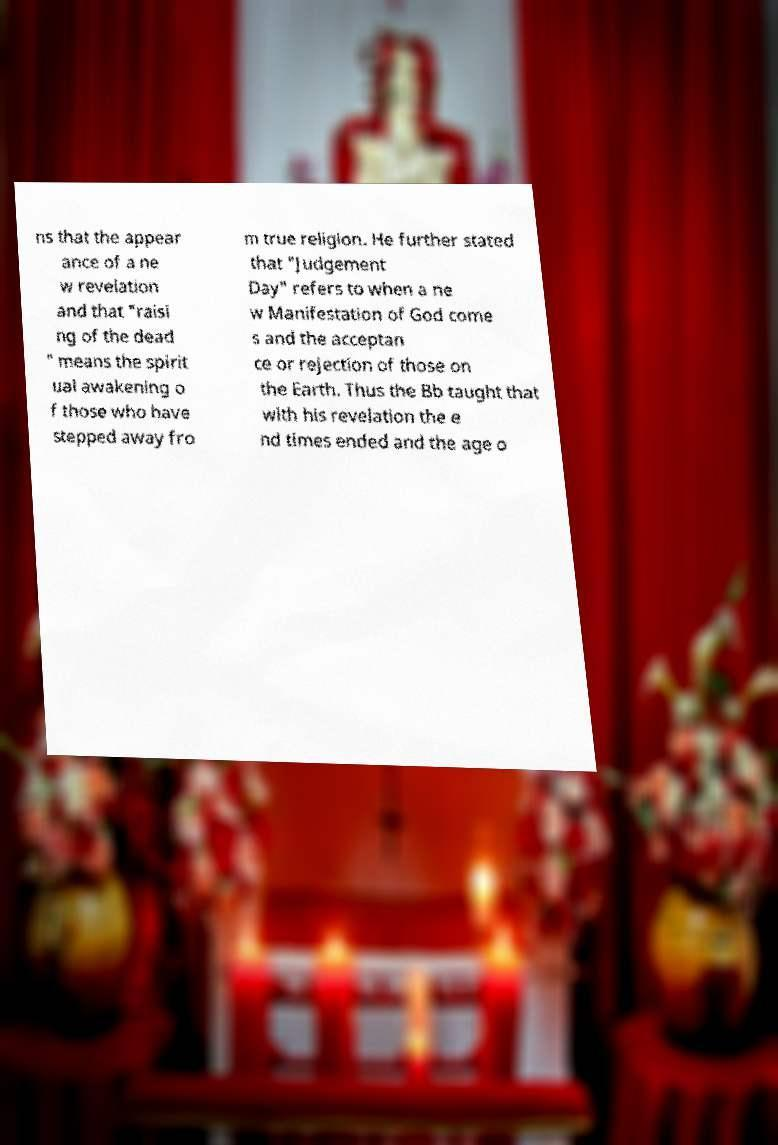I need the written content from this picture converted into text. Can you do that? ns that the appear ance of a ne w revelation and that "raisi ng of the dead " means the spirit ual awakening o f those who have stepped away fro m true religion. He further stated that "Judgement Day" refers to when a ne w Manifestation of God come s and the acceptan ce or rejection of those on the Earth. Thus the Bb taught that with his revelation the e nd times ended and the age o 